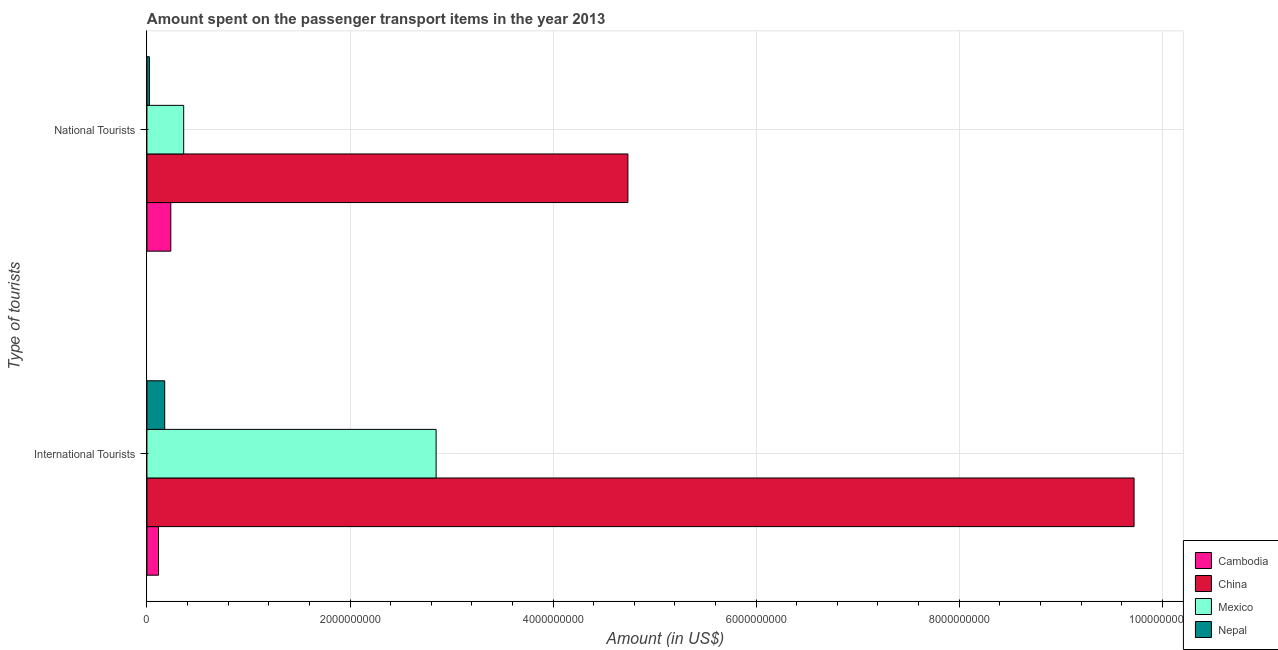How many different coloured bars are there?
Offer a very short reply. 4. Are the number of bars per tick equal to the number of legend labels?
Make the answer very short. Yes. How many bars are there on the 1st tick from the top?
Keep it short and to the point. 4. How many bars are there on the 2nd tick from the bottom?
Give a very brief answer. 4. What is the label of the 1st group of bars from the top?
Provide a short and direct response. National Tourists. What is the amount spent on transport items of national tourists in Cambodia?
Make the answer very short. 2.35e+08. Across all countries, what is the maximum amount spent on transport items of international tourists?
Provide a short and direct response. 9.72e+09. Across all countries, what is the minimum amount spent on transport items of national tourists?
Give a very brief answer. 2.40e+07. In which country was the amount spent on transport items of international tourists maximum?
Provide a succinct answer. China. In which country was the amount spent on transport items of international tourists minimum?
Your answer should be compact. Cambodia. What is the total amount spent on transport items of international tourists in the graph?
Make the answer very short. 1.29e+1. What is the difference between the amount spent on transport items of international tourists in Nepal and that in Mexico?
Your answer should be very brief. -2.67e+09. What is the difference between the amount spent on transport items of national tourists in China and the amount spent on transport items of international tourists in Mexico?
Provide a short and direct response. 1.89e+09. What is the average amount spent on transport items of international tourists per country?
Make the answer very short. 3.21e+09. What is the difference between the amount spent on transport items of national tourists and amount spent on transport items of international tourists in Cambodia?
Your answer should be compact. 1.21e+08. What is the ratio of the amount spent on transport items of international tourists in Cambodia to that in Mexico?
Ensure brevity in your answer.  0.04. Is the amount spent on transport items of national tourists in Mexico less than that in China?
Your answer should be very brief. Yes. In how many countries, is the amount spent on transport items of national tourists greater than the average amount spent on transport items of national tourists taken over all countries?
Your answer should be compact. 1. What does the 4th bar from the top in International Tourists represents?
Offer a terse response. Cambodia. Are all the bars in the graph horizontal?
Give a very brief answer. Yes. Are the values on the major ticks of X-axis written in scientific E-notation?
Offer a terse response. No. Does the graph contain any zero values?
Keep it short and to the point. No. Where does the legend appear in the graph?
Provide a short and direct response. Bottom right. What is the title of the graph?
Your answer should be very brief. Amount spent on the passenger transport items in the year 2013. What is the label or title of the X-axis?
Your answer should be compact. Amount (in US$). What is the label or title of the Y-axis?
Give a very brief answer. Type of tourists. What is the Amount (in US$) of Cambodia in International Tourists?
Give a very brief answer. 1.14e+08. What is the Amount (in US$) in China in International Tourists?
Your answer should be compact. 9.72e+09. What is the Amount (in US$) in Mexico in International Tourists?
Give a very brief answer. 2.85e+09. What is the Amount (in US$) of Nepal in International Tourists?
Your answer should be compact. 1.75e+08. What is the Amount (in US$) in Cambodia in National Tourists?
Offer a very short reply. 2.35e+08. What is the Amount (in US$) of China in National Tourists?
Provide a succinct answer. 4.74e+09. What is the Amount (in US$) in Mexico in National Tourists?
Make the answer very short. 3.62e+08. What is the Amount (in US$) of Nepal in National Tourists?
Provide a short and direct response. 2.40e+07. Across all Type of tourists, what is the maximum Amount (in US$) in Cambodia?
Your response must be concise. 2.35e+08. Across all Type of tourists, what is the maximum Amount (in US$) of China?
Give a very brief answer. 9.72e+09. Across all Type of tourists, what is the maximum Amount (in US$) of Mexico?
Offer a very short reply. 2.85e+09. Across all Type of tourists, what is the maximum Amount (in US$) in Nepal?
Keep it short and to the point. 1.75e+08. Across all Type of tourists, what is the minimum Amount (in US$) in Cambodia?
Make the answer very short. 1.14e+08. Across all Type of tourists, what is the minimum Amount (in US$) of China?
Ensure brevity in your answer.  4.74e+09. Across all Type of tourists, what is the minimum Amount (in US$) of Mexico?
Provide a short and direct response. 3.62e+08. Across all Type of tourists, what is the minimum Amount (in US$) of Nepal?
Provide a succinct answer. 2.40e+07. What is the total Amount (in US$) of Cambodia in the graph?
Give a very brief answer. 3.49e+08. What is the total Amount (in US$) in China in the graph?
Keep it short and to the point. 1.45e+1. What is the total Amount (in US$) in Mexico in the graph?
Keep it short and to the point. 3.21e+09. What is the total Amount (in US$) of Nepal in the graph?
Your answer should be compact. 1.99e+08. What is the difference between the Amount (in US$) of Cambodia in International Tourists and that in National Tourists?
Your response must be concise. -1.21e+08. What is the difference between the Amount (in US$) of China in International Tourists and that in National Tourists?
Offer a very short reply. 4.98e+09. What is the difference between the Amount (in US$) in Mexico in International Tourists and that in National Tourists?
Provide a short and direct response. 2.49e+09. What is the difference between the Amount (in US$) in Nepal in International Tourists and that in National Tourists?
Give a very brief answer. 1.51e+08. What is the difference between the Amount (in US$) in Cambodia in International Tourists and the Amount (in US$) in China in National Tourists?
Provide a succinct answer. -4.62e+09. What is the difference between the Amount (in US$) of Cambodia in International Tourists and the Amount (in US$) of Mexico in National Tourists?
Offer a terse response. -2.48e+08. What is the difference between the Amount (in US$) of Cambodia in International Tourists and the Amount (in US$) of Nepal in National Tourists?
Your answer should be very brief. 9.00e+07. What is the difference between the Amount (in US$) in China in International Tourists and the Amount (in US$) in Mexico in National Tourists?
Your response must be concise. 9.36e+09. What is the difference between the Amount (in US$) in China in International Tourists and the Amount (in US$) in Nepal in National Tourists?
Your answer should be very brief. 9.70e+09. What is the difference between the Amount (in US$) of Mexico in International Tourists and the Amount (in US$) of Nepal in National Tourists?
Make the answer very short. 2.82e+09. What is the average Amount (in US$) in Cambodia per Type of tourists?
Keep it short and to the point. 1.74e+08. What is the average Amount (in US$) of China per Type of tourists?
Give a very brief answer. 7.23e+09. What is the average Amount (in US$) in Mexico per Type of tourists?
Keep it short and to the point. 1.60e+09. What is the average Amount (in US$) of Nepal per Type of tourists?
Provide a short and direct response. 9.95e+07. What is the difference between the Amount (in US$) in Cambodia and Amount (in US$) in China in International Tourists?
Give a very brief answer. -9.61e+09. What is the difference between the Amount (in US$) in Cambodia and Amount (in US$) in Mexico in International Tourists?
Provide a succinct answer. -2.73e+09. What is the difference between the Amount (in US$) in Cambodia and Amount (in US$) in Nepal in International Tourists?
Your response must be concise. -6.10e+07. What is the difference between the Amount (in US$) of China and Amount (in US$) of Mexico in International Tourists?
Offer a very short reply. 6.87e+09. What is the difference between the Amount (in US$) in China and Amount (in US$) in Nepal in International Tourists?
Provide a short and direct response. 9.55e+09. What is the difference between the Amount (in US$) of Mexico and Amount (in US$) of Nepal in International Tourists?
Your response must be concise. 2.67e+09. What is the difference between the Amount (in US$) in Cambodia and Amount (in US$) in China in National Tourists?
Keep it short and to the point. -4.50e+09. What is the difference between the Amount (in US$) in Cambodia and Amount (in US$) in Mexico in National Tourists?
Your answer should be compact. -1.27e+08. What is the difference between the Amount (in US$) of Cambodia and Amount (in US$) of Nepal in National Tourists?
Offer a very short reply. 2.11e+08. What is the difference between the Amount (in US$) of China and Amount (in US$) of Mexico in National Tourists?
Offer a terse response. 4.38e+09. What is the difference between the Amount (in US$) of China and Amount (in US$) of Nepal in National Tourists?
Make the answer very short. 4.71e+09. What is the difference between the Amount (in US$) of Mexico and Amount (in US$) of Nepal in National Tourists?
Offer a terse response. 3.38e+08. What is the ratio of the Amount (in US$) of Cambodia in International Tourists to that in National Tourists?
Ensure brevity in your answer.  0.49. What is the ratio of the Amount (in US$) of China in International Tourists to that in National Tourists?
Your answer should be compact. 2.05. What is the ratio of the Amount (in US$) of Mexico in International Tourists to that in National Tourists?
Ensure brevity in your answer.  7.87. What is the ratio of the Amount (in US$) in Nepal in International Tourists to that in National Tourists?
Provide a short and direct response. 7.29. What is the difference between the highest and the second highest Amount (in US$) of Cambodia?
Your response must be concise. 1.21e+08. What is the difference between the highest and the second highest Amount (in US$) in China?
Provide a short and direct response. 4.98e+09. What is the difference between the highest and the second highest Amount (in US$) in Mexico?
Make the answer very short. 2.49e+09. What is the difference between the highest and the second highest Amount (in US$) in Nepal?
Offer a terse response. 1.51e+08. What is the difference between the highest and the lowest Amount (in US$) in Cambodia?
Ensure brevity in your answer.  1.21e+08. What is the difference between the highest and the lowest Amount (in US$) of China?
Provide a succinct answer. 4.98e+09. What is the difference between the highest and the lowest Amount (in US$) of Mexico?
Ensure brevity in your answer.  2.49e+09. What is the difference between the highest and the lowest Amount (in US$) in Nepal?
Your answer should be very brief. 1.51e+08. 